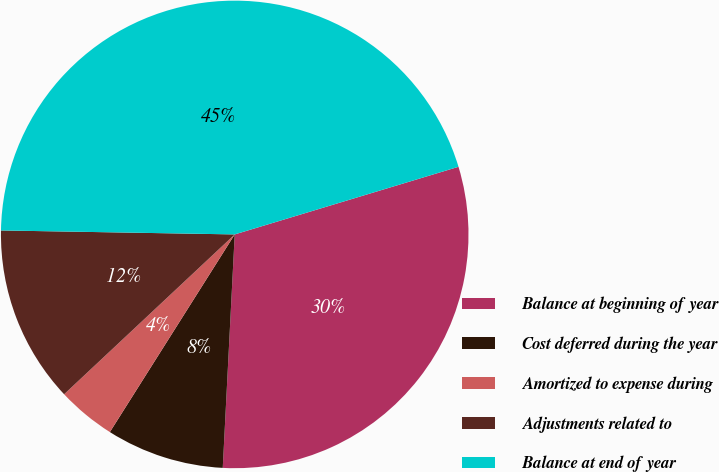<chart> <loc_0><loc_0><loc_500><loc_500><pie_chart><fcel>Balance at beginning of year<fcel>Cost deferred during the year<fcel>Amortized to expense during<fcel>Adjustments related to<fcel>Balance at end of year<nl><fcel>30.48%<fcel>8.15%<fcel>4.05%<fcel>12.25%<fcel>45.05%<nl></chart> 